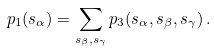<formula> <loc_0><loc_0><loc_500><loc_500>p _ { 1 } ( s _ { \alpha } ) = \sum _ { s _ { \beta } , s _ { \gamma } } p _ { 3 } ( s _ { \alpha } , s _ { \beta } , s _ { \gamma } ) \, .</formula> 